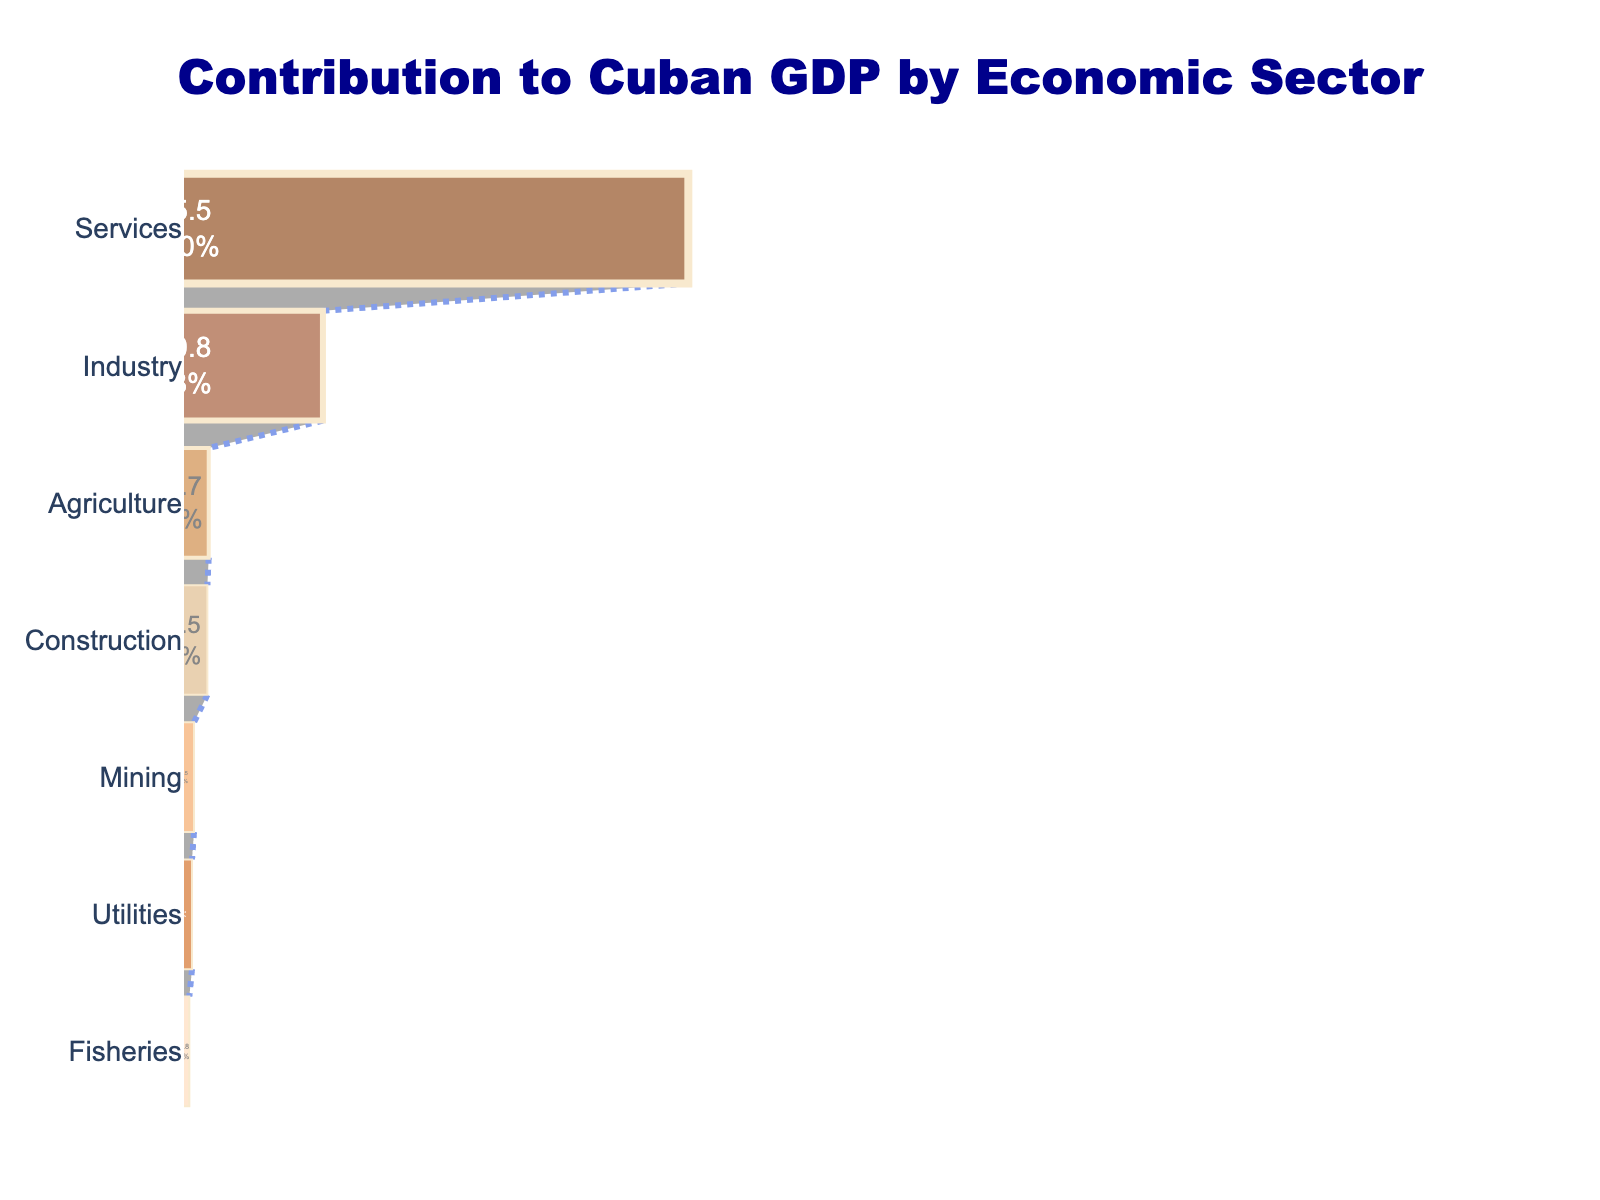What is the title of the funnel chart? The title of the funnel chart is located at the top of the figure and it clearly states the context of the data being visualized.
Answer: Contribution to Cuban GDP by Economic Sector Which sector has the largest contribution to Cuban GDP? By looking at the top of the funnel chart, we see that Services is the first sector listed with the largest bar.
Answer: Services What is the combined contribution percentage of Agriculture and Fisheries sectors? Add the percentages for Agriculture (3.7%) and Fisheries (0.8%) to find the combined contribution. 3.7 + 0.8 = 4.5
Answer: 4.5% Which two sectors have the smallest contributions to Cuban GDP? Identify the bottom two sectors in the funnel chart by looking at the smallest areas.
Answer: Utilities and Fisheries What is the difference in contribution percentage between the Industry and Construction sectors? Subtract the percentage for Construction (3.5%) from the percentage for Industry (20.8%). 20.8 - 3.5 = 17.3
Answer: 17.3% How many sectors contribute more than 10% to the Cuban GDP? Count the number of sectors with contributions greater than 10% by referring to the bar lengths. Only Services (75.5%) and Industry (20.8%) are above 10%.
Answer: 2 What percentage is contributed by all sectors combined except Services? Subtract the percentage of Services (75.5%) from the total GDP percentage (100%). 100 - 75.5 = 24.5
Answer: 24.5% Which sector contributes a higher percentage to the GDP, Mining or Utilities? Compare the percentages for Mining (1.5%) and Utilities (1.2%) to determine which is higher.
Answer: Mining What is the average contribution percentage of the bottom three sectors? Add the percentages for the bottom three sectors (Construction, Mining, and Utilities: 3.5 + 1.5 + 1.2) and then divide by 3. (3.5 + 1.5 + 1.2) / 3 = 2.07
Answer: 2.07% What is a unique feature of a funnel chart shown in this figure? The funnel chart visually represents the data from largest to smallest in a funnel-like shape, which helps in understanding the relative importance of each sector and the diminishing contributions as one moves down the chart.
Answer: Funnel shape representing diminishing contributions 